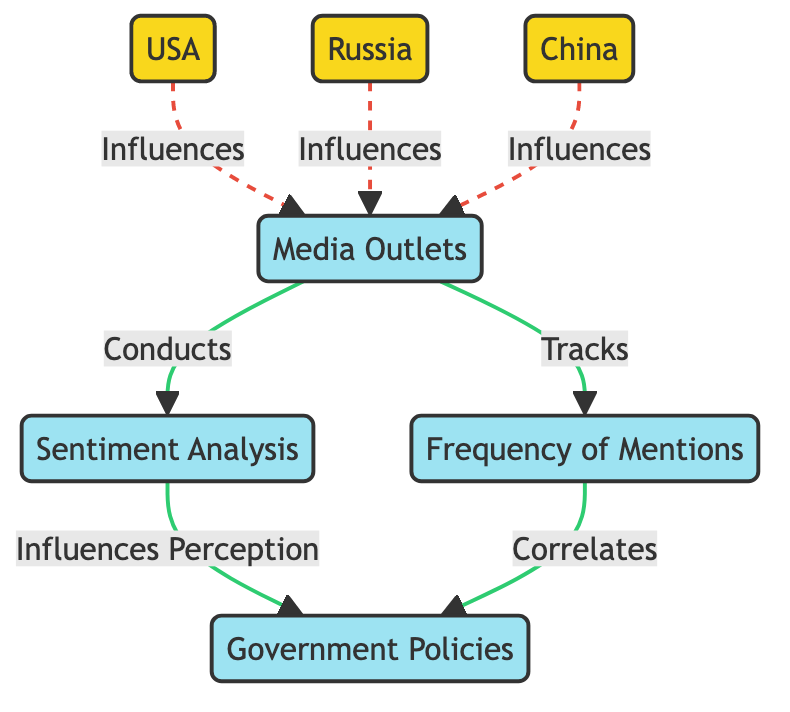What is the influence of media outlets on sentiment analysis? The diagram shows a direct relationship where media outlets conduct sentiment analysis. Therefore, media outlets influence sentiment analysis directly.
Answer: Conducts How many countries are represented in this diagram? In the diagram, three countries are represented: USA, Russia, and China. Therefore, the total number of countries is three.
Answer: 3 What do sentiment analysis and frequency of mentions correlate with? Sentiment analysis influences perception, while frequency of mentions correlates with government policies. So, both connect to government policies.
Answer: Government Policies What is the color of the media outlets node? The media outlets node has a specific class definition for color, which is light yellow (#f9d71c). Therefore, the answer is light yellow.
Answer: Light yellow Which country influences media outlets the most? In the diagram, all three countries (USA, Russia, and China) influence media outlets equally. However, to determine "most," we can say they are all part of the same level of influence.
Answer: All equally How many edges connect media outlets to other nodes? There are four connections (edges) extending from media outlets to sentiment analysis and frequency of mentions, with each having one direct connection.
Answer: 2 What does frequency of mentions correlate with, based on the diagram? The frequency of mentions directly correlates with government policies as shown in the diagram.
Answer: Government Policies Which type of nodes experience dashed edges? The dashed edges in the diagram (styled as stroke-dasharray) represent the connections from the three countries to the media outlets, indicating a different type of relationship than others in the diagram.
Answer: Three countries What does sentiment analysis influence, according to the diagram? Sentiment analysis influences perception, which then shows a relationship to government policies as well, thereby creating a clear flow of influence.
Answer: Perception 